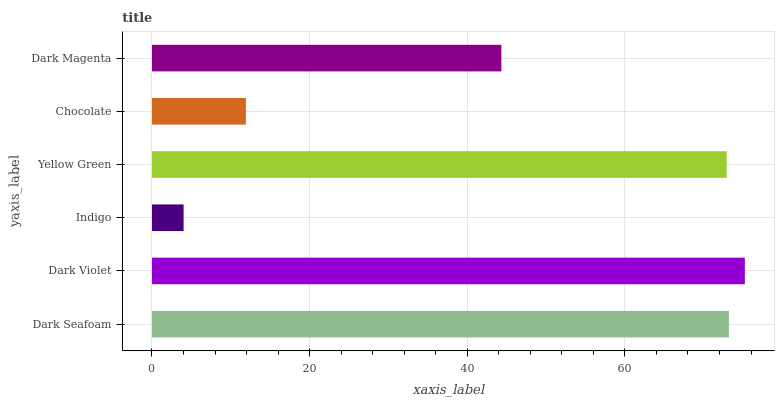Is Indigo the minimum?
Answer yes or no. Yes. Is Dark Violet the maximum?
Answer yes or no. Yes. Is Dark Violet the minimum?
Answer yes or no. No. Is Indigo the maximum?
Answer yes or no. No. Is Dark Violet greater than Indigo?
Answer yes or no. Yes. Is Indigo less than Dark Violet?
Answer yes or no. Yes. Is Indigo greater than Dark Violet?
Answer yes or no. No. Is Dark Violet less than Indigo?
Answer yes or no. No. Is Yellow Green the high median?
Answer yes or no. Yes. Is Dark Magenta the low median?
Answer yes or no. Yes. Is Dark Magenta the high median?
Answer yes or no. No. Is Dark Seafoam the low median?
Answer yes or no. No. 